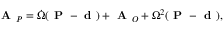<formula> <loc_0><loc_0><loc_500><loc_500>{ A } _ { P } = { \dot { \Omega } } ( { P } - { d } ) + { A } _ { O } + \Omega ^ { 2 } ( { P } - { d } ) ,</formula> 